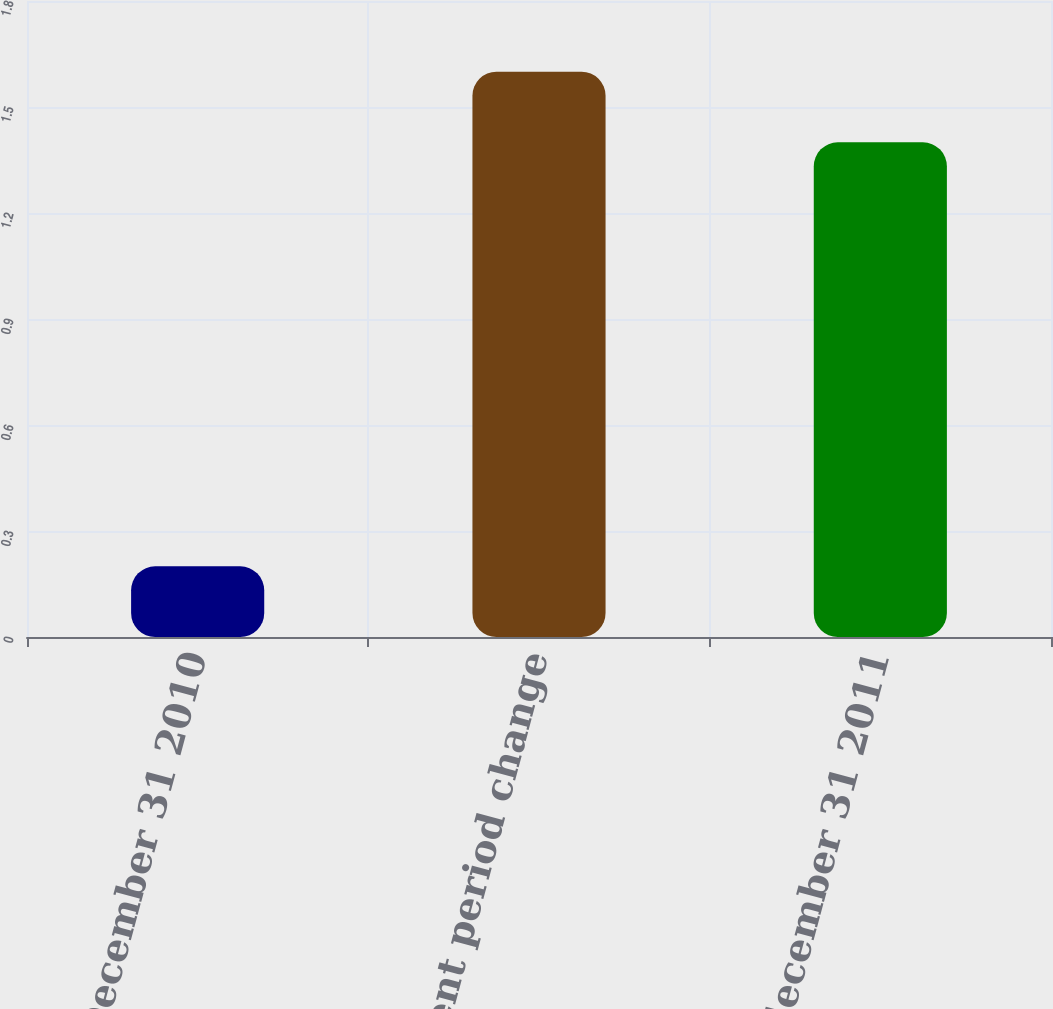Convert chart to OTSL. <chart><loc_0><loc_0><loc_500><loc_500><bar_chart><fcel>Balance at December 31 2010<fcel>Current period change<fcel>Balance at december 31 2011<nl><fcel>0.2<fcel>1.6<fcel>1.4<nl></chart> 